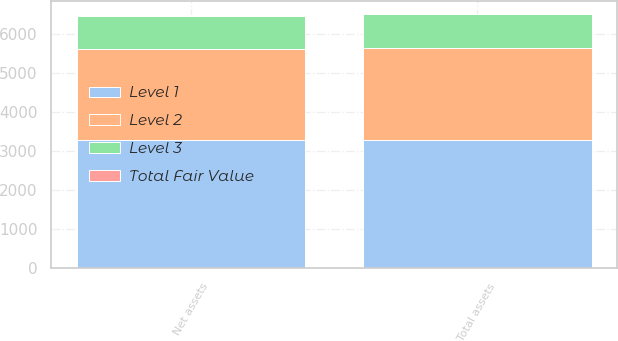<chart> <loc_0><loc_0><loc_500><loc_500><stacked_bar_chart><ecel><fcel>Total assets<fcel>Net assets<nl><fcel>Level 1<fcel>3294<fcel>3278<nl><fcel>Level 2<fcel>2346<fcel>2346<nl><fcel>Level 3<fcel>868<fcel>852<nl><fcel>Total Fair Value<fcel>3<fcel>3<nl></chart> 